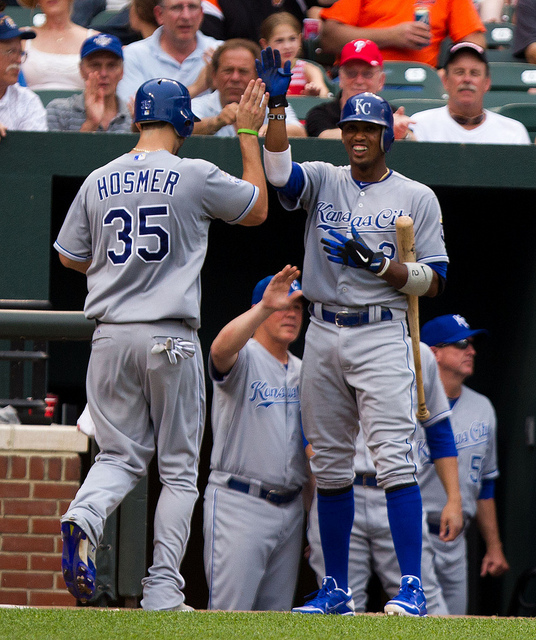Please identify all text content in this image. HOSMER 35 kc 2 5 Ci Kansas 